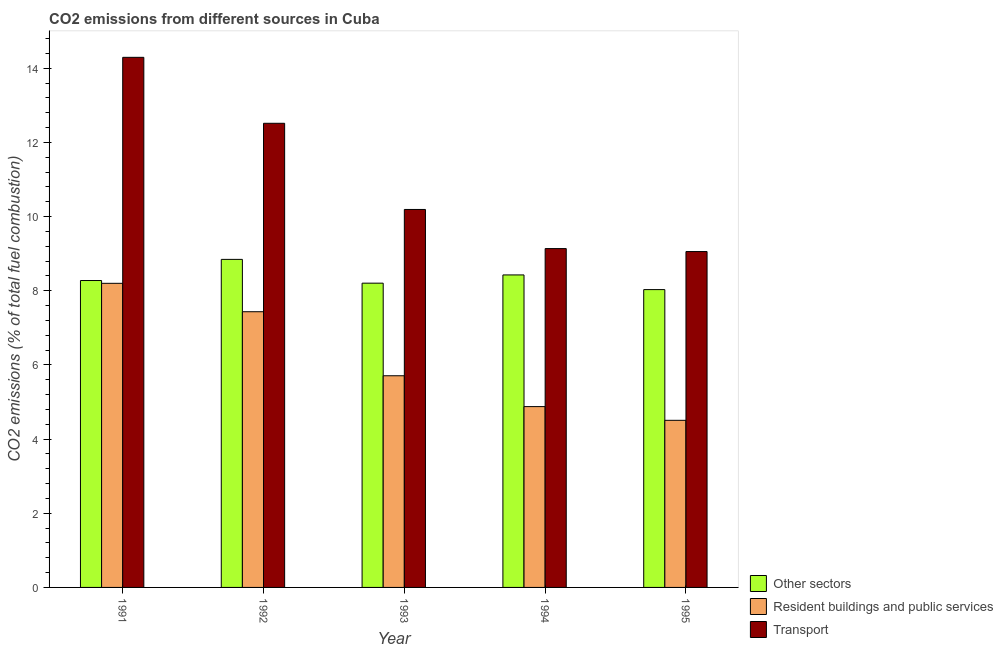How many different coloured bars are there?
Your answer should be compact. 3. How many bars are there on the 3rd tick from the left?
Offer a terse response. 3. How many bars are there on the 3rd tick from the right?
Provide a short and direct response. 3. What is the percentage of co2 emissions from transport in 1993?
Offer a very short reply. 10.19. Across all years, what is the maximum percentage of co2 emissions from resident buildings and public services?
Keep it short and to the point. 8.2. Across all years, what is the minimum percentage of co2 emissions from transport?
Offer a very short reply. 9.06. In which year was the percentage of co2 emissions from resident buildings and public services maximum?
Ensure brevity in your answer.  1991. What is the total percentage of co2 emissions from other sectors in the graph?
Your answer should be compact. 41.79. What is the difference between the percentage of co2 emissions from other sectors in 1993 and that in 1995?
Give a very brief answer. 0.17. What is the difference between the percentage of co2 emissions from transport in 1991 and the percentage of co2 emissions from resident buildings and public services in 1994?
Provide a succinct answer. 5.16. What is the average percentage of co2 emissions from other sectors per year?
Ensure brevity in your answer.  8.36. What is the ratio of the percentage of co2 emissions from transport in 1992 to that in 1995?
Offer a terse response. 1.38. Is the difference between the percentage of co2 emissions from resident buildings and public services in 1992 and 1993 greater than the difference between the percentage of co2 emissions from transport in 1992 and 1993?
Ensure brevity in your answer.  No. What is the difference between the highest and the second highest percentage of co2 emissions from transport?
Give a very brief answer. 1.78. What is the difference between the highest and the lowest percentage of co2 emissions from transport?
Provide a short and direct response. 5.24. In how many years, is the percentage of co2 emissions from transport greater than the average percentage of co2 emissions from transport taken over all years?
Keep it short and to the point. 2. What does the 3rd bar from the left in 1994 represents?
Offer a terse response. Transport. What does the 1st bar from the right in 1991 represents?
Make the answer very short. Transport. Are all the bars in the graph horizontal?
Ensure brevity in your answer.  No. How many years are there in the graph?
Offer a terse response. 5. Does the graph contain any zero values?
Keep it short and to the point. No. Where does the legend appear in the graph?
Your answer should be very brief. Bottom right. How are the legend labels stacked?
Provide a short and direct response. Vertical. What is the title of the graph?
Ensure brevity in your answer.  CO2 emissions from different sources in Cuba. What is the label or title of the X-axis?
Make the answer very short. Year. What is the label or title of the Y-axis?
Your answer should be very brief. CO2 emissions (% of total fuel combustion). What is the CO2 emissions (% of total fuel combustion) in Other sectors in 1991?
Offer a terse response. 8.28. What is the CO2 emissions (% of total fuel combustion) of Resident buildings and public services in 1991?
Your answer should be compact. 8.2. What is the CO2 emissions (% of total fuel combustion) in Transport in 1991?
Provide a short and direct response. 14.3. What is the CO2 emissions (% of total fuel combustion) in Other sectors in 1992?
Keep it short and to the point. 8.85. What is the CO2 emissions (% of total fuel combustion) of Resident buildings and public services in 1992?
Provide a succinct answer. 7.44. What is the CO2 emissions (% of total fuel combustion) in Transport in 1992?
Offer a very short reply. 12.52. What is the CO2 emissions (% of total fuel combustion) in Other sectors in 1993?
Make the answer very short. 8.21. What is the CO2 emissions (% of total fuel combustion) in Resident buildings and public services in 1993?
Keep it short and to the point. 5.71. What is the CO2 emissions (% of total fuel combustion) of Transport in 1993?
Provide a succinct answer. 10.19. What is the CO2 emissions (% of total fuel combustion) in Other sectors in 1994?
Give a very brief answer. 8.43. What is the CO2 emissions (% of total fuel combustion) of Resident buildings and public services in 1994?
Offer a terse response. 4.88. What is the CO2 emissions (% of total fuel combustion) in Transport in 1994?
Keep it short and to the point. 9.14. What is the CO2 emissions (% of total fuel combustion) of Other sectors in 1995?
Ensure brevity in your answer.  8.03. What is the CO2 emissions (% of total fuel combustion) of Resident buildings and public services in 1995?
Your answer should be compact. 4.51. What is the CO2 emissions (% of total fuel combustion) in Transport in 1995?
Offer a very short reply. 9.06. Across all years, what is the maximum CO2 emissions (% of total fuel combustion) in Other sectors?
Your response must be concise. 8.85. Across all years, what is the maximum CO2 emissions (% of total fuel combustion) of Resident buildings and public services?
Your answer should be very brief. 8.2. Across all years, what is the maximum CO2 emissions (% of total fuel combustion) in Transport?
Your answer should be very brief. 14.3. Across all years, what is the minimum CO2 emissions (% of total fuel combustion) of Other sectors?
Offer a very short reply. 8.03. Across all years, what is the minimum CO2 emissions (% of total fuel combustion) of Resident buildings and public services?
Provide a succinct answer. 4.51. Across all years, what is the minimum CO2 emissions (% of total fuel combustion) of Transport?
Your response must be concise. 9.06. What is the total CO2 emissions (% of total fuel combustion) of Other sectors in the graph?
Offer a terse response. 41.79. What is the total CO2 emissions (% of total fuel combustion) in Resident buildings and public services in the graph?
Offer a very short reply. 30.73. What is the total CO2 emissions (% of total fuel combustion) in Transport in the graph?
Make the answer very short. 55.2. What is the difference between the CO2 emissions (% of total fuel combustion) in Other sectors in 1991 and that in 1992?
Offer a very short reply. -0.57. What is the difference between the CO2 emissions (% of total fuel combustion) in Resident buildings and public services in 1991 and that in 1992?
Your answer should be compact. 0.77. What is the difference between the CO2 emissions (% of total fuel combustion) in Transport in 1991 and that in 1992?
Your answer should be very brief. 1.78. What is the difference between the CO2 emissions (% of total fuel combustion) in Other sectors in 1991 and that in 1993?
Offer a terse response. 0.07. What is the difference between the CO2 emissions (% of total fuel combustion) of Resident buildings and public services in 1991 and that in 1993?
Your answer should be compact. 2.49. What is the difference between the CO2 emissions (% of total fuel combustion) of Transport in 1991 and that in 1993?
Your answer should be very brief. 4.1. What is the difference between the CO2 emissions (% of total fuel combustion) in Other sectors in 1991 and that in 1994?
Your answer should be very brief. -0.15. What is the difference between the CO2 emissions (% of total fuel combustion) in Resident buildings and public services in 1991 and that in 1994?
Your answer should be compact. 3.32. What is the difference between the CO2 emissions (% of total fuel combustion) of Transport in 1991 and that in 1994?
Provide a short and direct response. 5.16. What is the difference between the CO2 emissions (% of total fuel combustion) of Other sectors in 1991 and that in 1995?
Your response must be concise. 0.24. What is the difference between the CO2 emissions (% of total fuel combustion) in Resident buildings and public services in 1991 and that in 1995?
Your response must be concise. 3.69. What is the difference between the CO2 emissions (% of total fuel combustion) of Transport in 1991 and that in 1995?
Provide a succinct answer. 5.24. What is the difference between the CO2 emissions (% of total fuel combustion) in Other sectors in 1992 and that in 1993?
Your answer should be very brief. 0.64. What is the difference between the CO2 emissions (% of total fuel combustion) in Resident buildings and public services in 1992 and that in 1993?
Offer a very short reply. 1.73. What is the difference between the CO2 emissions (% of total fuel combustion) in Transport in 1992 and that in 1993?
Ensure brevity in your answer.  2.32. What is the difference between the CO2 emissions (% of total fuel combustion) in Other sectors in 1992 and that in 1994?
Offer a very short reply. 0.42. What is the difference between the CO2 emissions (% of total fuel combustion) in Resident buildings and public services in 1992 and that in 1994?
Keep it short and to the point. 2.56. What is the difference between the CO2 emissions (% of total fuel combustion) in Transport in 1992 and that in 1994?
Offer a terse response. 3.38. What is the difference between the CO2 emissions (% of total fuel combustion) of Other sectors in 1992 and that in 1995?
Offer a terse response. 0.81. What is the difference between the CO2 emissions (% of total fuel combustion) in Resident buildings and public services in 1992 and that in 1995?
Your answer should be compact. 2.93. What is the difference between the CO2 emissions (% of total fuel combustion) of Transport in 1992 and that in 1995?
Offer a very short reply. 3.46. What is the difference between the CO2 emissions (% of total fuel combustion) of Other sectors in 1993 and that in 1994?
Your answer should be very brief. -0.22. What is the difference between the CO2 emissions (% of total fuel combustion) of Resident buildings and public services in 1993 and that in 1994?
Keep it short and to the point. 0.83. What is the difference between the CO2 emissions (% of total fuel combustion) in Transport in 1993 and that in 1994?
Keep it short and to the point. 1.06. What is the difference between the CO2 emissions (% of total fuel combustion) in Other sectors in 1993 and that in 1995?
Ensure brevity in your answer.  0.17. What is the difference between the CO2 emissions (% of total fuel combustion) of Resident buildings and public services in 1993 and that in 1995?
Ensure brevity in your answer.  1.2. What is the difference between the CO2 emissions (% of total fuel combustion) of Transport in 1993 and that in 1995?
Give a very brief answer. 1.14. What is the difference between the CO2 emissions (% of total fuel combustion) of Other sectors in 1994 and that in 1995?
Your response must be concise. 0.4. What is the difference between the CO2 emissions (% of total fuel combustion) in Resident buildings and public services in 1994 and that in 1995?
Offer a very short reply. 0.37. What is the difference between the CO2 emissions (% of total fuel combustion) in Transport in 1994 and that in 1995?
Offer a terse response. 0.08. What is the difference between the CO2 emissions (% of total fuel combustion) of Other sectors in 1991 and the CO2 emissions (% of total fuel combustion) of Resident buildings and public services in 1992?
Make the answer very short. 0.84. What is the difference between the CO2 emissions (% of total fuel combustion) in Other sectors in 1991 and the CO2 emissions (% of total fuel combustion) in Transport in 1992?
Make the answer very short. -4.24. What is the difference between the CO2 emissions (% of total fuel combustion) of Resident buildings and public services in 1991 and the CO2 emissions (% of total fuel combustion) of Transport in 1992?
Provide a succinct answer. -4.32. What is the difference between the CO2 emissions (% of total fuel combustion) of Other sectors in 1991 and the CO2 emissions (% of total fuel combustion) of Resident buildings and public services in 1993?
Offer a very short reply. 2.57. What is the difference between the CO2 emissions (% of total fuel combustion) of Other sectors in 1991 and the CO2 emissions (% of total fuel combustion) of Transport in 1993?
Offer a terse response. -1.92. What is the difference between the CO2 emissions (% of total fuel combustion) in Resident buildings and public services in 1991 and the CO2 emissions (% of total fuel combustion) in Transport in 1993?
Make the answer very short. -1.99. What is the difference between the CO2 emissions (% of total fuel combustion) in Other sectors in 1991 and the CO2 emissions (% of total fuel combustion) in Resident buildings and public services in 1994?
Offer a very short reply. 3.4. What is the difference between the CO2 emissions (% of total fuel combustion) in Other sectors in 1991 and the CO2 emissions (% of total fuel combustion) in Transport in 1994?
Provide a short and direct response. -0.86. What is the difference between the CO2 emissions (% of total fuel combustion) in Resident buildings and public services in 1991 and the CO2 emissions (% of total fuel combustion) in Transport in 1994?
Provide a short and direct response. -0.94. What is the difference between the CO2 emissions (% of total fuel combustion) in Other sectors in 1991 and the CO2 emissions (% of total fuel combustion) in Resident buildings and public services in 1995?
Keep it short and to the point. 3.77. What is the difference between the CO2 emissions (% of total fuel combustion) in Other sectors in 1991 and the CO2 emissions (% of total fuel combustion) in Transport in 1995?
Your answer should be very brief. -0.78. What is the difference between the CO2 emissions (% of total fuel combustion) of Resident buildings and public services in 1991 and the CO2 emissions (% of total fuel combustion) of Transport in 1995?
Provide a succinct answer. -0.86. What is the difference between the CO2 emissions (% of total fuel combustion) in Other sectors in 1992 and the CO2 emissions (% of total fuel combustion) in Resident buildings and public services in 1993?
Provide a short and direct response. 3.14. What is the difference between the CO2 emissions (% of total fuel combustion) of Other sectors in 1992 and the CO2 emissions (% of total fuel combustion) of Transport in 1993?
Keep it short and to the point. -1.35. What is the difference between the CO2 emissions (% of total fuel combustion) in Resident buildings and public services in 1992 and the CO2 emissions (% of total fuel combustion) in Transport in 1993?
Provide a succinct answer. -2.76. What is the difference between the CO2 emissions (% of total fuel combustion) of Other sectors in 1992 and the CO2 emissions (% of total fuel combustion) of Resident buildings and public services in 1994?
Offer a terse response. 3.97. What is the difference between the CO2 emissions (% of total fuel combustion) of Other sectors in 1992 and the CO2 emissions (% of total fuel combustion) of Transport in 1994?
Offer a very short reply. -0.29. What is the difference between the CO2 emissions (% of total fuel combustion) of Resident buildings and public services in 1992 and the CO2 emissions (% of total fuel combustion) of Transport in 1994?
Your response must be concise. -1.7. What is the difference between the CO2 emissions (% of total fuel combustion) of Other sectors in 1992 and the CO2 emissions (% of total fuel combustion) of Resident buildings and public services in 1995?
Provide a short and direct response. 4.34. What is the difference between the CO2 emissions (% of total fuel combustion) of Other sectors in 1992 and the CO2 emissions (% of total fuel combustion) of Transport in 1995?
Offer a terse response. -0.21. What is the difference between the CO2 emissions (% of total fuel combustion) in Resident buildings and public services in 1992 and the CO2 emissions (% of total fuel combustion) in Transport in 1995?
Make the answer very short. -1.62. What is the difference between the CO2 emissions (% of total fuel combustion) of Other sectors in 1993 and the CO2 emissions (% of total fuel combustion) of Resident buildings and public services in 1994?
Keep it short and to the point. 3.33. What is the difference between the CO2 emissions (% of total fuel combustion) of Other sectors in 1993 and the CO2 emissions (% of total fuel combustion) of Transport in 1994?
Your answer should be compact. -0.93. What is the difference between the CO2 emissions (% of total fuel combustion) in Resident buildings and public services in 1993 and the CO2 emissions (% of total fuel combustion) in Transport in 1994?
Provide a succinct answer. -3.43. What is the difference between the CO2 emissions (% of total fuel combustion) in Other sectors in 1993 and the CO2 emissions (% of total fuel combustion) in Resident buildings and public services in 1995?
Give a very brief answer. 3.7. What is the difference between the CO2 emissions (% of total fuel combustion) in Other sectors in 1993 and the CO2 emissions (% of total fuel combustion) in Transport in 1995?
Make the answer very short. -0.85. What is the difference between the CO2 emissions (% of total fuel combustion) in Resident buildings and public services in 1993 and the CO2 emissions (% of total fuel combustion) in Transport in 1995?
Make the answer very short. -3.35. What is the difference between the CO2 emissions (% of total fuel combustion) in Other sectors in 1994 and the CO2 emissions (% of total fuel combustion) in Resident buildings and public services in 1995?
Provide a succinct answer. 3.92. What is the difference between the CO2 emissions (% of total fuel combustion) of Other sectors in 1994 and the CO2 emissions (% of total fuel combustion) of Transport in 1995?
Your answer should be very brief. -0.63. What is the difference between the CO2 emissions (% of total fuel combustion) in Resident buildings and public services in 1994 and the CO2 emissions (% of total fuel combustion) in Transport in 1995?
Ensure brevity in your answer.  -4.18. What is the average CO2 emissions (% of total fuel combustion) in Other sectors per year?
Your answer should be compact. 8.36. What is the average CO2 emissions (% of total fuel combustion) in Resident buildings and public services per year?
Keep it short and to the point. 6.15. What is the average CO2 emissions (% of total fuel combustion) of Transport per year?
Give a very brief answer. 11.04. In the year 1991, what is the difference between the CO2 emissions (% of total fuel combustion) of Other sectors and CO2 emissions (% of total fuel combustion) of Resident buildings and public services?
Ensure brevity in your answer.  0.08. In the year 1991, what is the difference between the CO2 emissions (% of total fuel combustion) in Other sectors and CO2 emissions (% of total fuel combustion) in Transport?
Your response must be concise. -6.02. In the year 1991, what is the difference between the CO2 emissions (% of total fuel combustion) in Resident buildings and public services and CO2 emissions (% of total fuel combustion) in Transport?
Give a very brief answer. -6.09. In the year 1992, what is the difference between the CO2 emissions (% of total fuel combustion) in Other sectors and CO2 emissions (% of total fuel combustion) in Resident buildings and public services?
Make the answer very short. 1.41. In the year 1992, what is the difference between the CO2 emissions (% of total fuel combustion) of Other sectors and CO2 emissions (% of total fuel combustion) of Transport?
Provide a succinct answer. -3.67. In the year 1992, what is the difference between the CO2 emissions (% of total fuel combustion) in Resident buildings and public services and CO2 emissions (% of total fuel combustion) in Transport?
Your answer should be very brief. -5.08. In the year 1993, what is the difference between the CO2 emissions (% of total fuel combustion) of Other sectors and CO2 emissions (% of total fuel combustion) of Resident buildings and public services?
Your answer should be compact. 2.5. In the year 1993, what is the difference between the CO2 emissions (% of total fuel combustion) in Other sectors and CO2 emissions (% of total fuel combustion) in Transport?
Make the answer very short. -1.99. In the year 1993, what is the difference between the CO2 emissions (% of total fuel combustion) in Resident buildings and public services and CO2 emissions (% of total fuel combustion) in Transport?
Provide a succinct answer. -4.49. In the year 1994, what is the difference between the CO2 emissions (% of total fuel combustion) of Other sectors and CO2 emissions (% of total fuel combustion) of Resident buildings and public services?
Keep it short and to the point. 3.55. In the year 1994, what is the difference between the CO2 emissions (% of total fuel combustion) in Other sectors and CO2 emissions (% of total fuel combustion) in Transport?
Your response must be concise. -0.71. In the year 1994, what is the difference between the CO2 emissions (% of total fuel combustion) in Resident buildings and public services and CO2 emissions (% of total fuel combustion) in Transport?
Ensure brevity in your answer.  -4.26. In the year 1995, what is the difference between the CO2 emissions (% of total fuel combustion) in Other sectors and CO2 emissions (% of total fuel combustion) in Resident buildings and public services?
Your answer should be very brief. 3.53. In the year 1995, what is the difference between the CO2 emissions (% of total fuel combustion) in Other sectors and CO2 emissions (% of total fuel combustion) in Transport?
Your answer should be compact. -1.03. In the year 1995, what is the difference between the CO2 emissions (% of total fuel combustion) of Resident buildings and public services and CO2 emissions (% of total fuel combustion) of Transport?
Provide a short and direct response. -4.55. What is the ratio of the CO2 emissions (% of total fuel combustion) of Other sectors in 1991 to that in 1992?
Keep it short and to the point. 0.94. What is the ratio of the CO2 emissions (% of total fuel combustion) of Resident buildings and public services in 1991 to that in 1992?
Ensure brevity in your answer.  1.1. What is the ratio of the CO2 emissions (% of total fuel combustion) in Transport in 1991 to that in 1992?
Offer a terse response. 1.14. What is the ratio of the CO2 emissions (% of total fuel combustion) of Other sectors in 1991 to that in 1993?
Offer a terse response. 1.01. What is the ratio of the CO2 emissions (% of total fuel combustion) in Resident buildings and public services in 1991 to that in 1993?
Your response must be concise. 1.44. What is the ratio of the CO2 emissions (% of total fuel combustion) in Transport in 1991 to that in 1993?
Provide a short and direct response. 1.4. What is the ratio of the CO2 emissions (% of total fuel combustion) in Other sectors in 1991 to that in 1994?
Provide a succinct answer. 0.98. What is the ratio of the CO2 emissions (% of total fuel combustion) in Resident buildings and public services in 1991 to that in 1994?
Your answer should be compact. 1.68. What is the ratio of the CO2 emissions (% of total fuel combustion) in Transport in 1991 to that in 1994?
Ensure brevity in your answer.  1.56. What is the ratio of the CO2 emissions (% of total fuel combustion) in Other sectors in 1991 to that in 1995?
Offer a terse response. 1.03. What is the ratio of the CO2 emissions (% of total fuel combustion) of Resident buildings and public services in 1991 to that in 1995?
Your response must be concise. 1.82. What is the ratio of the CO2 emissions (% of total fuel combustion) in Transport in 1991 to that in 1995?
Give a very brief answer. 1.58. What is the ratio of the CO2 emissions (% of total fuel combustion) of Other sectors in 1992 to that in 1993?
Ensure brevity in your answer.  1.08. What is the ratio of the CO2 emissions (% of total fuel combustion) in Resident buildings and public services in 1992 to that in 1993?
Give a very brief answer. 1.3. What is the ratio of the CO2 emissions (% of total fuel combustion) in Transport in 1992 to that in 1993?
Keep it short and to the point. 1.23. What is the ratio of the CO2 emissions (% of total fuel combustion) of Other sectors in 1992 to that in 1994?
Your response must be concise. 1.05. What is the ratio of the CO2 emissions (% of total fuel combustion) in Resident buildings and public services in 1992 to that in 1994?
Offer a very short reply. 1.52. What is the ratio of the CO2 emissions (% of total fuel combustion) of Transport in 1992 to that in 1994?
Provide a short and direct response. 1.37. What is the ratio of the CO2 emissions (% of total fuel combustion) of Other sectors in 1992 to that in 1995?
Provide a succinct answer. 1.1. What is the ratio of the CO2 emissions (% of total fuel combustion) of Resident buildings and public services in 1992 to that in 1995?
Ensure brevity in your answer.  1.65. What is the ratio of the CO2 emissions (% of total fuel combustion) of Transport in 1992 to that in 1995?
Provide a succinct answer. 1.38. What is the ratio of the CO2 emissions (% of total fuel combustion) in Other sectors in 1993 to that in 1994?
Make the answer very short. 0.97. What is the ratio of the CO2 emissions (% of total fuel combustion) of Resident buildings and public services in 1993 to that in 1994?
Your answer should be compact. 1.17. What is the ratio of the CO2 emissions (% of total fuel combustion) in Transport in 1993 to that in 1994?
Provide a succinct answer. 1.12. What is the ratio of the CO2 emissions (% of total fuel combustion) in Other sectors in 1993 to that in 1995?
Make the answer very short. 1.02. What is the ratio of the CO2 emissions (% of total fuel combustion) in Resident buildings and public services in 1993 to that in 1995?
Your answer should be very brief. 1.27. What is the ratio of the CO2 emissions (% of total fuel combustion) of Transport in 1993 to that in 1995?
Offer a terse response. 1.13. What is the ratio of the CO2 emissions (% of total fuel combustion) of Other sectors in 1994 to that in 1995?
Your response must be concise. 1.05. What is the ratio of the CO2 emissions (% of total fuel combustion) in Resident buildings and public services in 1994 to that in 1995?
Your answer should be very brief. 1.08. What is the ratio of the CO2 emissions (% of total fuel combustion) of Transport in 1994 to that in 1995?
Make the answer very short. 1.01. What is the difference between the highest and the second highest CO2 emissions (% of total fuel combustion) of Other sectors?
Offer a very short reply. 0.42. What is the difference between the highest and the second highest CO2 emissions (% of total fuel combustion) in Resident buildings and public services?
Offer a terse response. 0.77. What is the difference between the highest and the second highest CO2 emissions (% of total fuel combustion) in Transport?
Your answer should be compact. 1.78. What is the difference between the highest and the lowest CO2 emissions (% of total fuel combustion) in Other sectors?
Give a very brief answer. 0.81. What is the difference between the highest and the lowest CO2 emissions (% of total fuel combustion) in Resident buildings and public services?
Your response must be concise. 3.69. What is the difference between the highest and the lowest CO2 emissions (% of total fuel combustion) in Transport?
Provide a succinct answer. 5.24. 